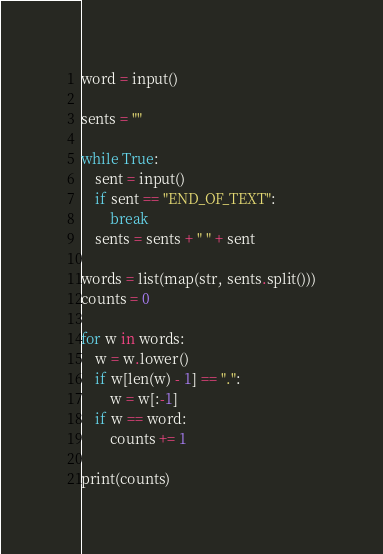<code> <loc_0><loc_0><loc_500><loc_500><_Python_>word = input()

sents = ""

while True:
    sent = input()
    if sent == "END_OF_TEXT":
        break
    sents = sents + " " + sent

words = list(map(str, sents.split()))
counts = 0

for w in words:
    w = w.lower()
    if w[len(w) - 1] == ".":
        w = w[:-1]
    if w == word:
        counts += 1

print(counts)
</code> 